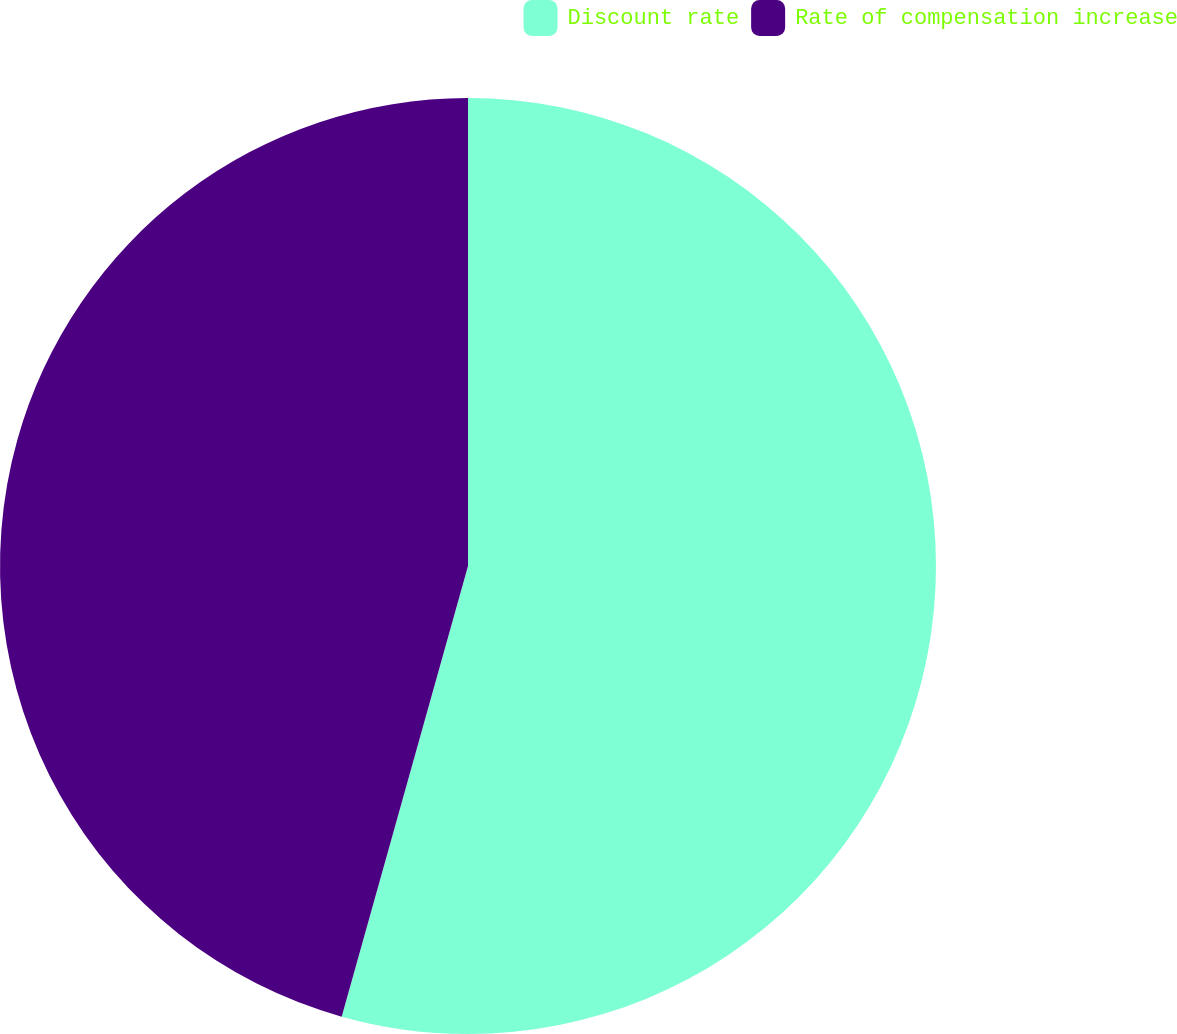<chart> <loc_0><loc_0><loc_500><loc_500><pie_chart><fcel>Discount rate<fcel>Rate of compensation increase<nl><fcel>54.35%<fcel>45.65%<nl></chart> 